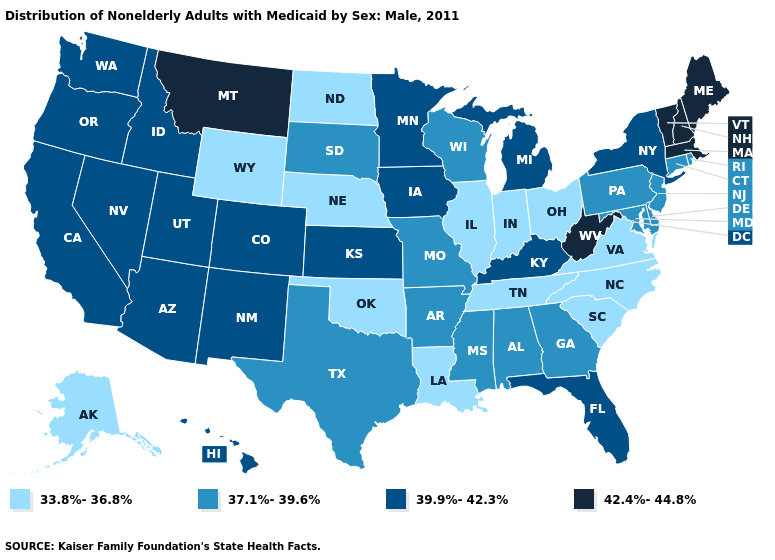Which states have the highest value in the USA?
Short answer required. Maine, Massachusetts, Montana, New Hampshire, Vermont, West Virginia. Does Delaware have the same value as Arkansas?
Keep it brief. Yes. What is the value of Iowa?
Be succinct. 39.9%-42.3%. Name the states that have a value in the range 39.9%-42.3%?
Concise answer only. Arizona, California, Colorado, Florida, Hawaii, Idaho, Iowa, Kansas, Kentucky, Michigan, Minnesota, Nevada, New Mexico, New York, Oregon, Utah, Washington. Which states hav the highest value in the West?
Short answer required. Montana. What is the lowest value in states that border Minnesota?
Short answer required. 33.8%-36.8%. Name the states that have a value in the range 42.4%-44.8%?
Write a very short answer. Maine, Massachusetts, Montana, New Hampshire, Vermont, West Virginia. Name the states that have a value in the range 39.9%-42.3%?
Keep it brief. Arizona, California, Colorado, Florida, Hawaii, Idaho, Iowa, Kansas, Kentucky, Michigan, Minnesota, Nevada, New Mexico, New York, Oregon, Utah, Washington. How many symbols are there in the legend?
Answer briefly. 4. Name the states that have a value in the range 42.4%-44.8%?
Answer briefly. Maine, Massachusetts, Montana, New Hampshire, Vermont, West Virginia. What is the highest value in states that border West Virginia?
Give a very brief answer. 39.9%-42.3%. Which states have the lowest value in the South?
Concise answer only. Louisiana, North Carolina, Oklahoma, South Carolina, Tennessee, Virginia. Which states hav the highest value in the West?
Write a very short answer. Montana. Name the states that have a value in the range 42.4%-44.8%?
Give a very brief answer. Maine, Massachusetts, Montana, New Hampshire, Vermont, West Virginia. How many symbols are there in the legend?
Be succinct. 4. 